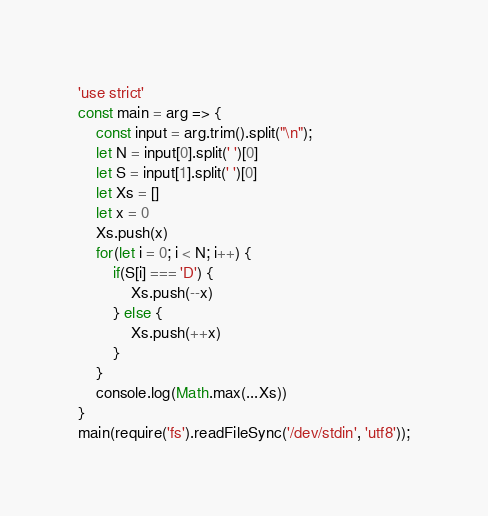Convert code to text. <code><loc_0><loc_0><loc_500><loc_500><_JavaScript_>'use strict'
const main = arg => {
	const input = arg.trim().split("\n");
	let N = input[0].split(' ')[0]
	let S = input[1].split(' ')[0]
	let Xs = []
	let x = 0
	Xs.push(x)
	for(let i = 0; i < N; i++) {
		if(S[i] === 'D') {
			Xs.push(--x)
		} else {
			Xs.push(++x)
		}
	}
	console.log(Math.max(...Xs))
}   
main(require('fs').readFileSync('/dev/stdin', 'utf8'));</code> 